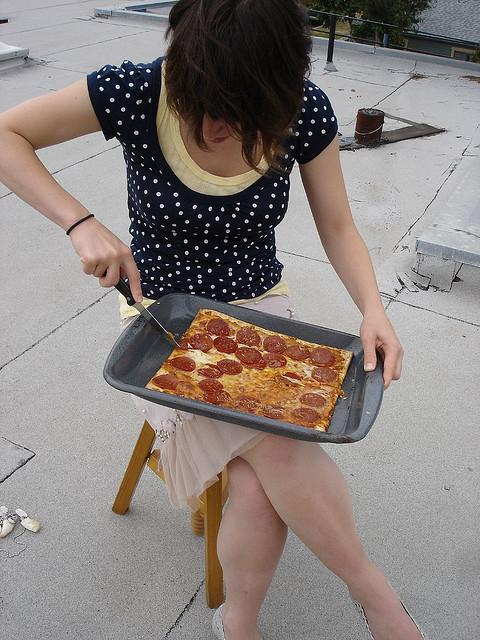What is different about this pizza than most pizzas?

Choices:
A) square shape
B) no cheese
C) all mushrooms
D) missing toppings square shape 